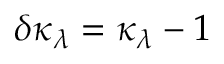<formula> <loc_0><loc_0><loc_500><loc_500>\delta \kappa _ { \lambda } = \kappa _ { \lambda } - 1</formula> 